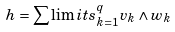Convert formula to latex. <formula><loc_0><loc_0><loc_500><loc_500>h = \sum \lim i t s _ { k = 1 } ^ { q } v _ { k } \wedge w _ { k }</formula> 